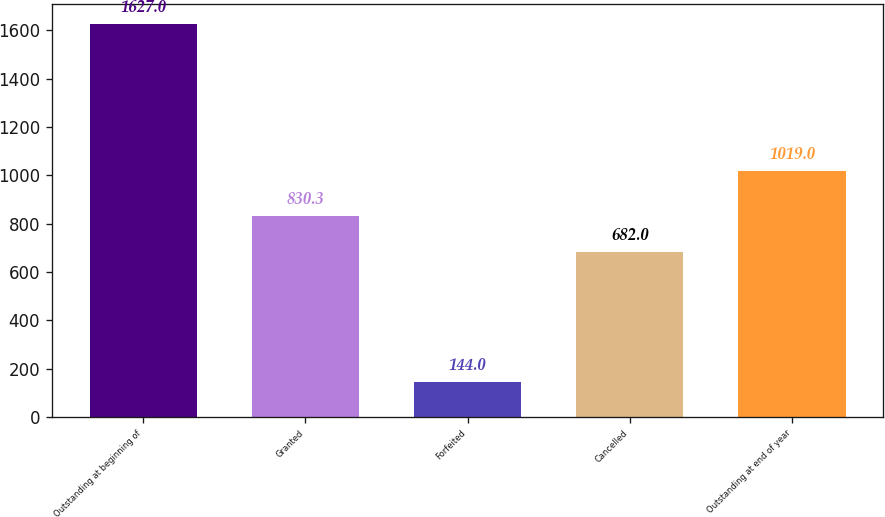Convert chart. <chart><loc_0><loc_0><loc_500><loc_500><bar_chart><fcel>Outstanding at beginning of<fcel>Granted<fcel>Forfeited<fcel>Cancelled<fcel>Outstanding at end of year<nl><fcel>1627<fcel>830.3<fcel>144<fcel>682<fcel>1019<nl></chart> 